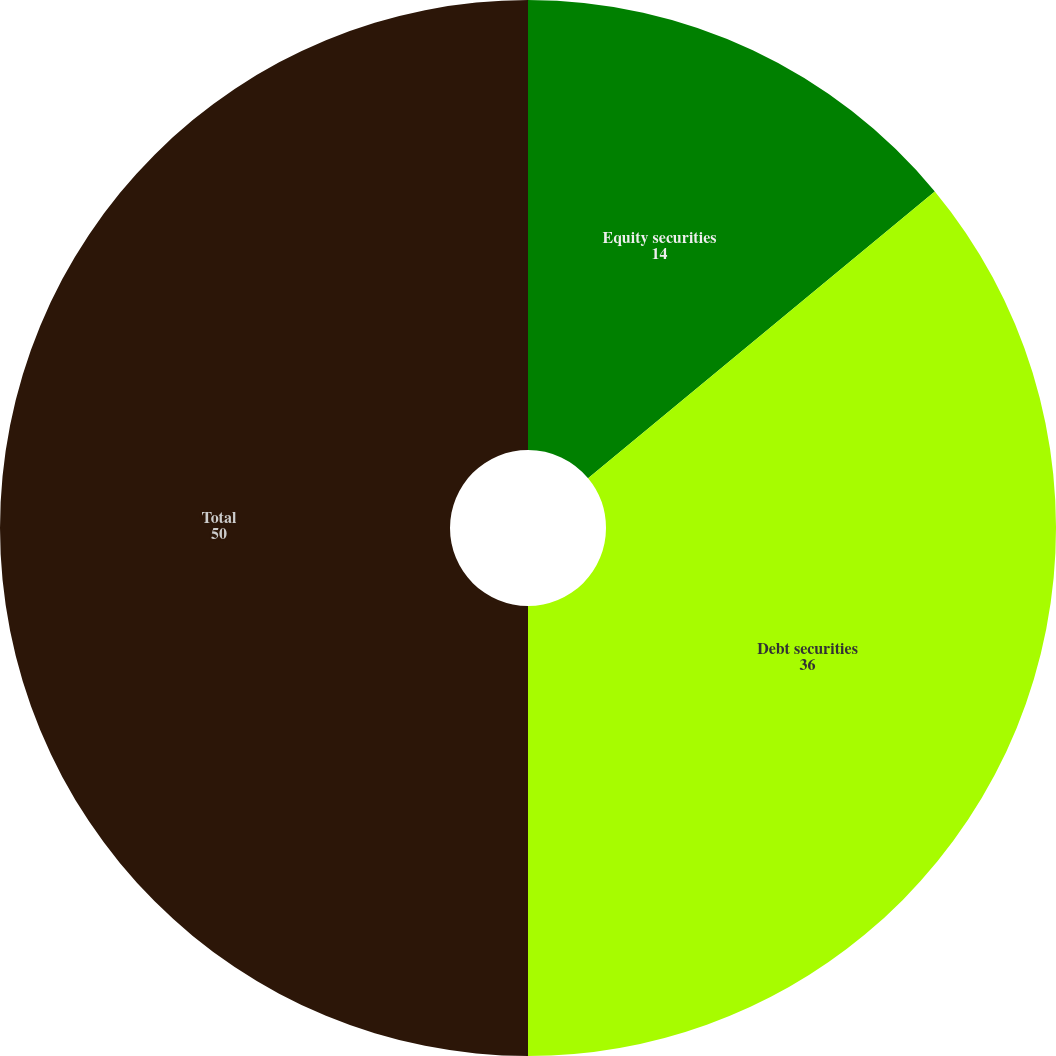<chart> <loc_0><loc_0><loc_500><loc_500><pie_chart><fcel>Equity securities<fcel>Debt securities<fcel>Total<nl><fcel>14.0%<fcel>36.0%<fcel>50.0%<nl></chart> 